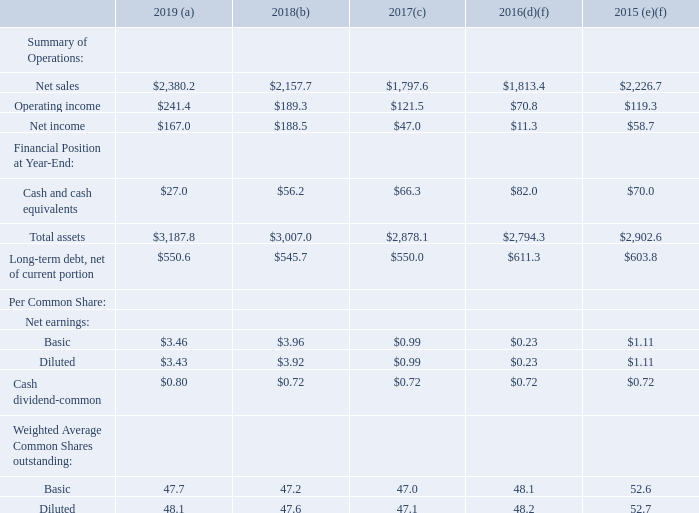Item 6. Selected Financial Data
Five-Year Financial Summary in millions, except per share data (Fiscal years ended June 30,)
(a) Fiscal year 2019 included $1.2 million of acquisition-related costs related to LPW Technology Ltd. See Note 4 in the Notes to the Consolidated Financial Statements included in Item 8. “Financial Statements and Supplementary Data” of this report.
(b) Fiscal year 2018 included $68.3 million of discrete income tax net benefits related to the U.S. tax reform and other legislative changes. See Note 17 in the Notes to the Consolidated Financial Statements included in Item 8. “Financial Statements and Supplementary Data” of this report.
(c) Fiscal year 2017 included $3.2 million of loss on divestiture of business. See Note 4 in the Notes to the Consolidated Financial Statements included in Item 8. "Financial Statements and Supplementary Data" of this report.
(d) Fiscal year 2016 included $22.5 million of excess inventory write-down charges, $12.5 million of goodwill impairment charges and $18.0 million of restructuring and impairment charges including $7.6 million of impairment of intangible assets and property, plant and equipment and $10.4 million of restructuring costs related primarily to an early retirement incentive and other severance related costs.
(e) Fiscal year 2015 included $29.1 million of restructuring costs related principally to workforce reduction, facility closures and write-down of certain assets.
(f) The weighted average common shares outstanding for fiscal years 2016 and 2015 included 5.5 million and 0.9 million less shares, respectively, related to the share repurchase program authorized in October 2014. During the fiscal years ended June 30, 2016 and 2015, we repurchased 3,762,200 shares and 2,995,272 shares, respectively, of common stock for $123.9 million and $124.5 million, respectively.
See Item 7. “Management’s Discussion and Analysis of Financial Condition and Results of Operations” for discussion of factors that affect the comparability of the “Selected Financial Data”.
What did Fiscal year 2019 include? $1.2 million of acquisition-related costs related to lpw technology ltd. What was the  Net sales for 2019?
Answer scale should be: million. $2,380.2. In which years was the amount of net sales provided? 2019, 2018, 2017, 2016, 2015. In which year was the Cash dividend-common the largest? $0.80>$0.72
Answer: 2019. What was the change in operating income in 2019 from 2018?
Answer scale should be: million. $241.4-$189.3
Answer: 52.1. What was the percentage change in operating income in 2019 from 2018?
Answer scale should be: percent. ($241.4-$189.3)/$189.3
Answer: 27.52. 